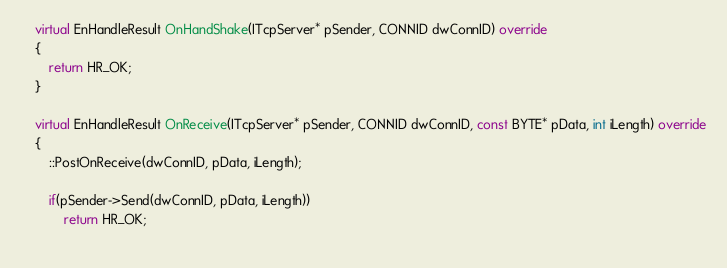Convert code to text. <code><loc_0><loc_0><loc_500><loc_500><_C++_>	virtual EnHandleResult OnHandShake(ITcpServer* pSender, CONNID dwConnID) override
	{
		return HR_OK;
	}

	virtual EnHandleResult OnReceive(ITcpServer* pSender, CONNID dwConnID, const BYTE* pData, int iLength) override
	{
		::PostOnReceive(dwConnID, pData, iLength);

		if(pSender->Send(dwConnID, pData, iLength))
			return HR_OK;
		</code> 